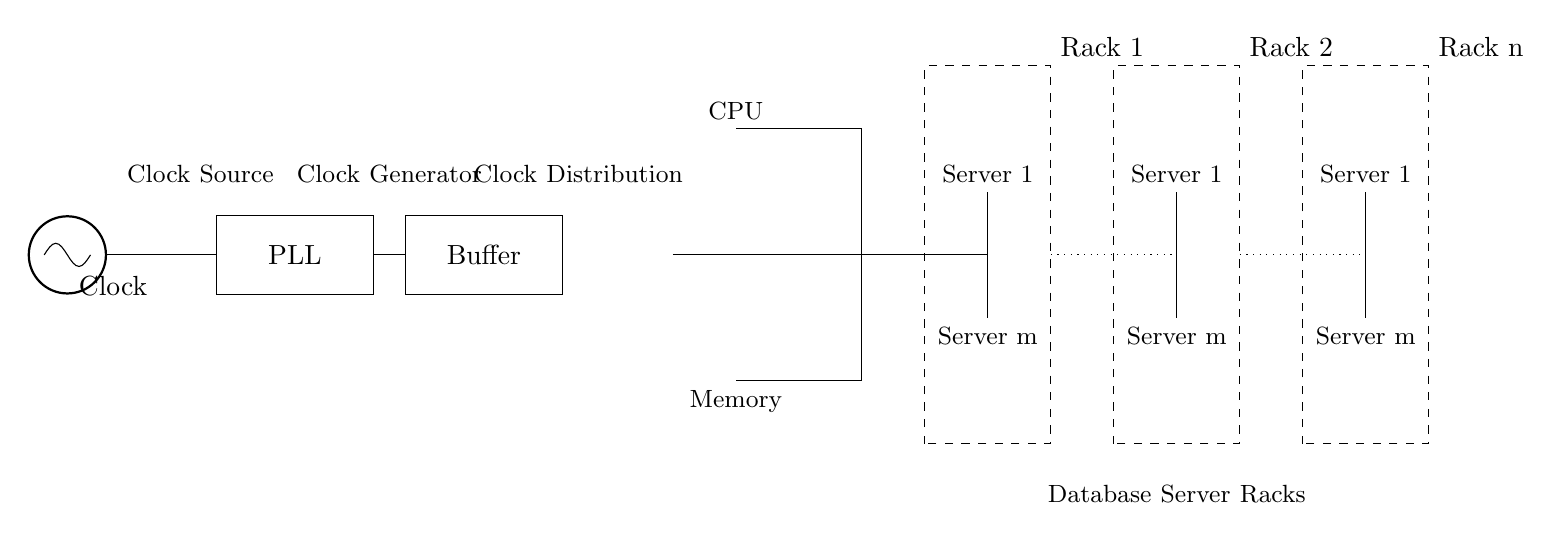What is the role of the PLL in the circuit? The PLL, or Phase-Locked Loop, acts to synchronize the output clock frequency with the input reference clock frequency, stabilizing the clock signal.
Answer: Synchronization How many server racks are depicted in the diagram? The diagram shows three server racks, which are labeled Rack 1, Rack 2, and Rack n.
Answer: Three What is between the clock buffer and the CPU in the circuit? The connection between the clock buffer and the CPU consists of a clock tree, which distributes the clock signal to various components.
Answer: Clock tree What component generates the clock signal in the circuit? The clock signal is generated by the oscillator, which is indicated at the start of the circuit.
Answer: Oscillator Describe the type of circuit depicted in the diagram. The circuit is a synchronous clock distribution network that ensures coordinated timing across different components in a large-scale server configuration.
Answer: Synchronous How does the clock signal reach the servers in the racks? The clock signal travels from the clock source to the PLL, then to the clock buffer and through the clock tree, leading to the various servers in the racks.
Answer: Through the clock distribution 